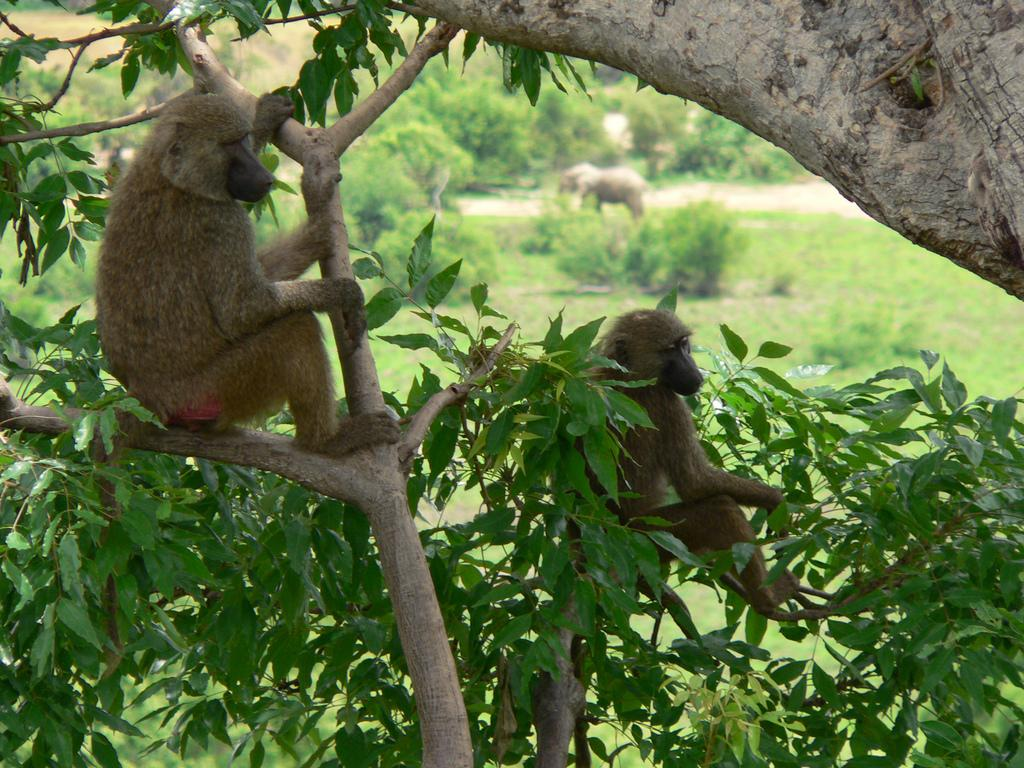What animals can be seen in the image? There are monkeys on the branches in the image. What type of vegetation is visible in the background of the image? There is grass and trees visible in the background of the image. What other large animal can be seen in the background of the image? There is an elephant in the background of the image. What type of ghost can be seen interacting with the monkeys in the image? There are no ghosts present in the image; it features monkeys on branches, grass, trees, and an elephant in the background. What season is depicted in the image, considering the presence of a ball? There is no ball present in the image, and therefore no indication of a specific season. 